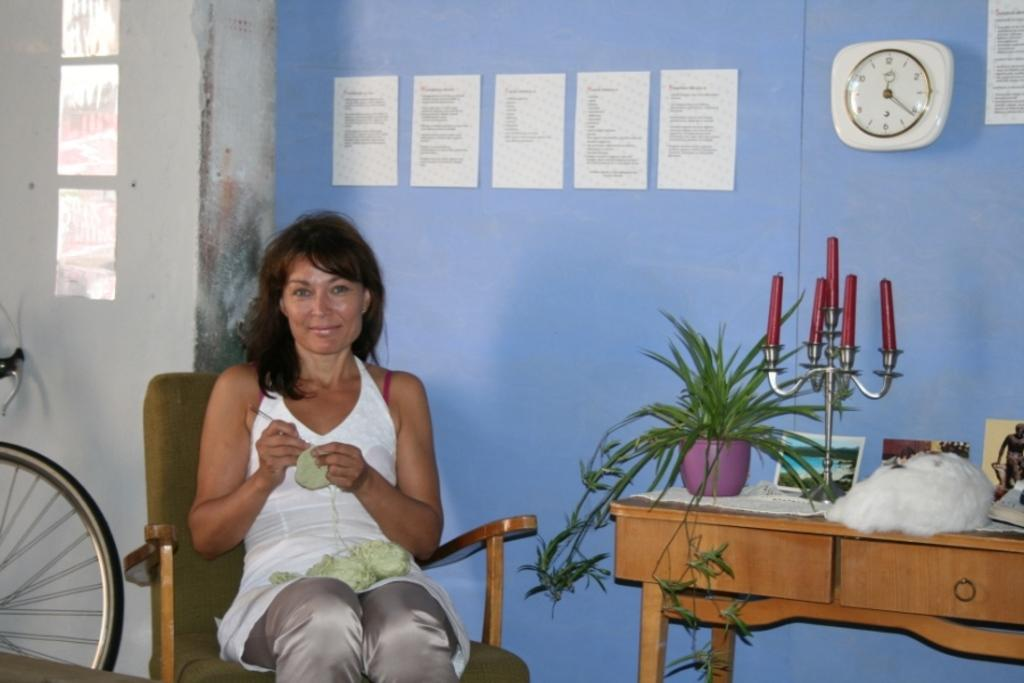Who is the main subject in the image? There is a lady in the image. Where is the lady located in the image? The lady is sitting at the left side of the image. What can be seen on the wall in the image? There is a clock on the wall in the image. What is present at the right side of the image? There is a desk at the right side of the image. What type of amusement can be seen on the desk in the image? There is no amusement present on the desk in the image. Is there an apple on the desk in the image? There is no apple present on the desk in the image. 